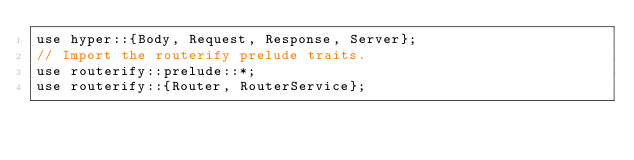<code> <loc_0><loc_0><loc_500><loc_500><_Rust_>use hyper::{Body, Request, Response, Server};
// Import the routerify prelude traits.
use routerify::prelude::*;
use routerify::{Router, RouterService};</code> 